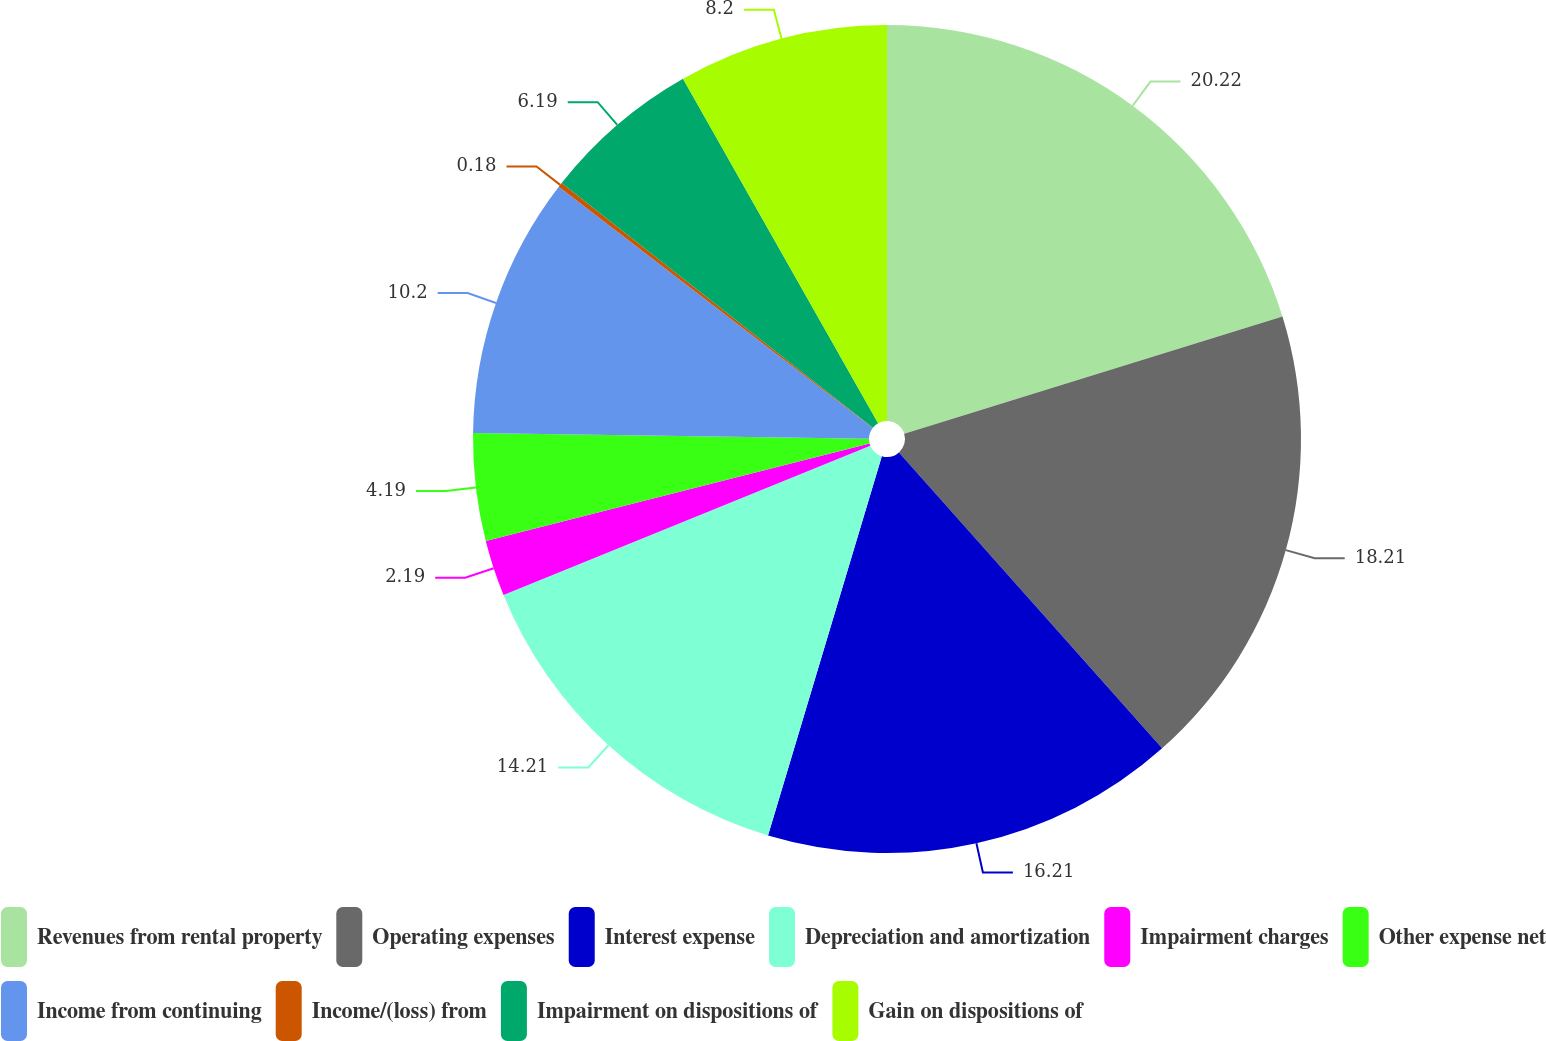<chart> <loc_0><loc_0><loc_500><loc_500><pie_chart><fcel>Revenues from rental property<fcel>Operating expenses<fcel>Interest expense<fcel>Depreciation and amortization<fcel>Impairment charges<fcel>Other expense net<fcel>Income from continuing<fcel>Income/(loss) from<fcel>Impairment on dispositions of<fcel>Gain on dispositions of<nl><fcel>20.22%<fcel>18.21%<fcel>16.21%<fcel>14.21%<fcel>2.19%<fcel>4.19%<fcel>10.2%<fcel>0.18%<fcel>6.19%<fcel>8.2%<nl></chart> 